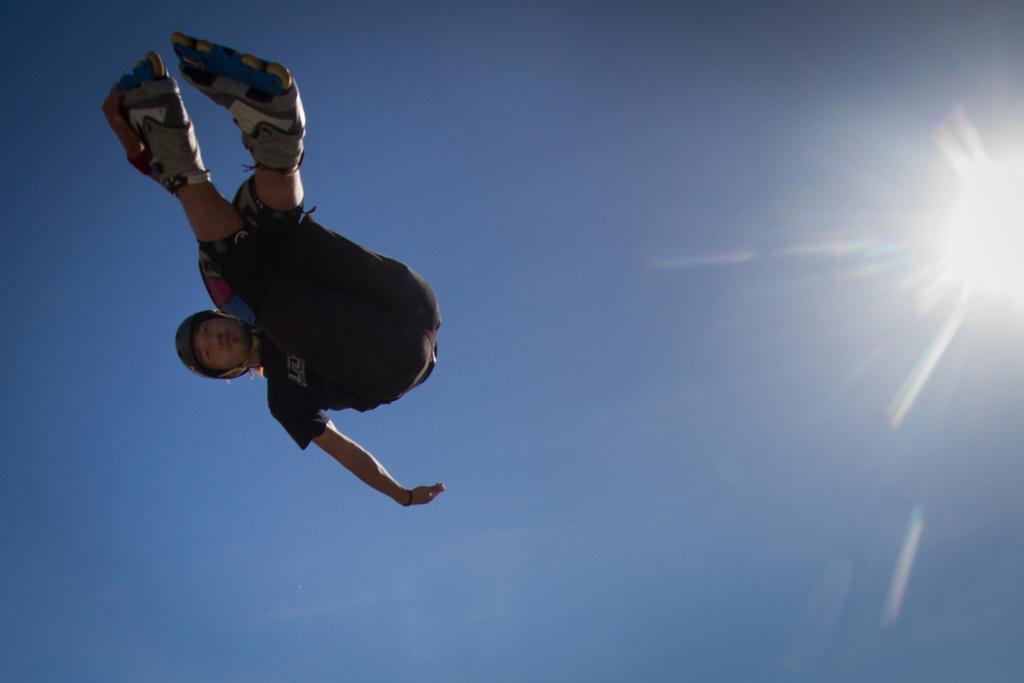In one or two sentences, can you explain what this image depicts? In the image there is a person jumping in the sky,behind him in the background there is a bright sunshine. 